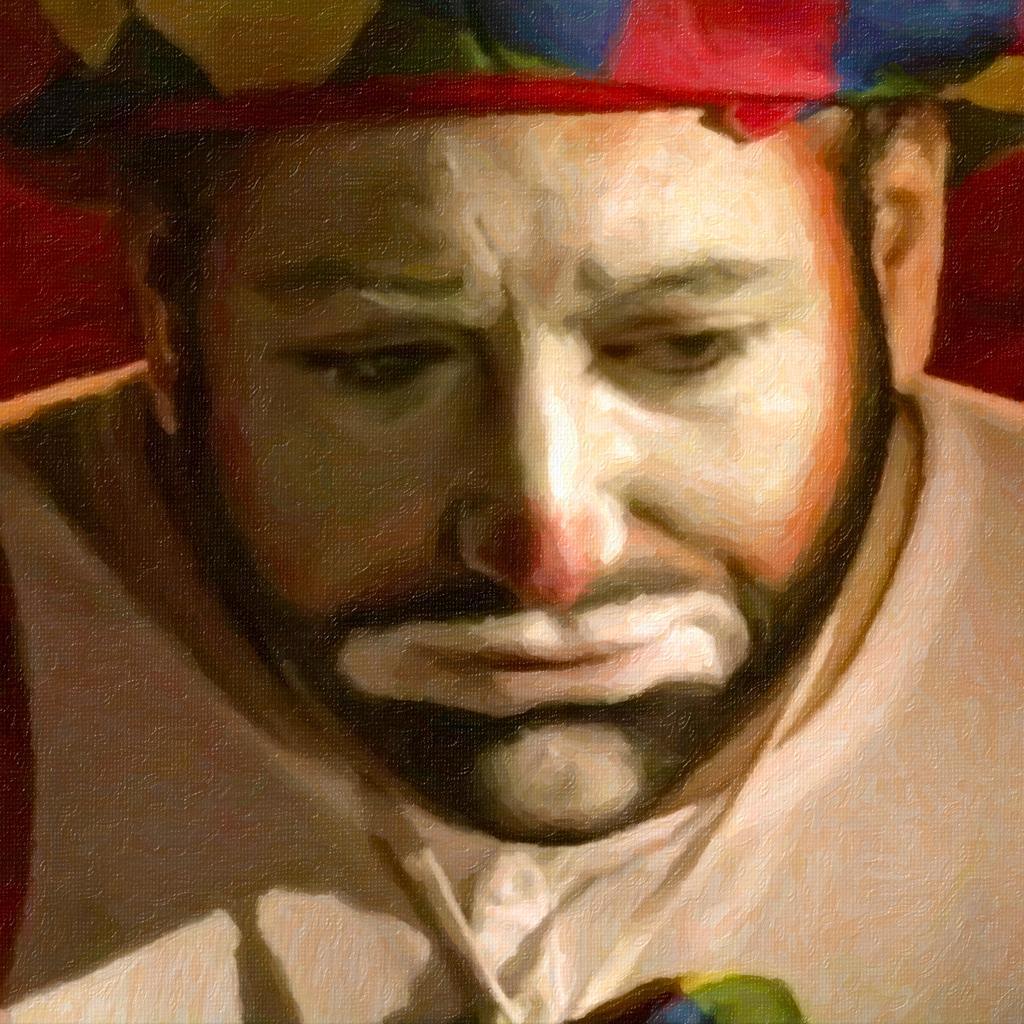In one or two sentences, can you explain what this image depicts? In this image we can see a painting of a person and on the face of the person white color paint is there. 